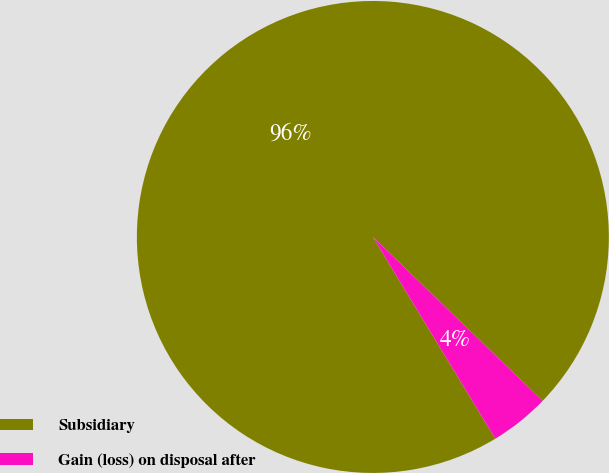Convert chart. <chart><loc_0><loc_0><loc_500><loc_500><pie_chart><fcel>Subsidiary<fcel>Gain (loss) on disposal after<nl><fcel>95.9%<fcel>4.1%<nl></chart> 